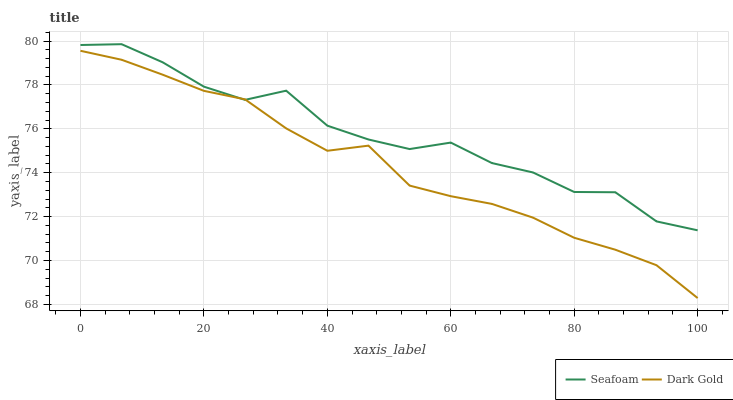Does Dark Gold have the minimum area under the curve?
Answer yes or no. Yes. Does Seafoam have the maximum area under the curve?
Answer yes or no. Yes. Does Dark Gold have the maximum area under the curve?
Answer yes or no. No. Is Dark Gold the smoothest?
Answer yes or no. Yes. Is Seafoam the roughest?
Answer yes or no. Yes. Is Dark Gold the roughest?
Answer yes or no. No. Does Dark Gold have the lowest value?
Answer yes or no. Yes. Does Seafoam have the highest value?
Answer yes or no. Yes. Does Dark Gold have the highest value?
Answer yes or no. No. Does Seafoam intersect Dark Gold?
Answer yes or no. Yes. Is Seafoam less than Dark Gold?
Answer yes or no. No. Is Seafoam greater than Dark Gold?
Answer yes or no. No. 